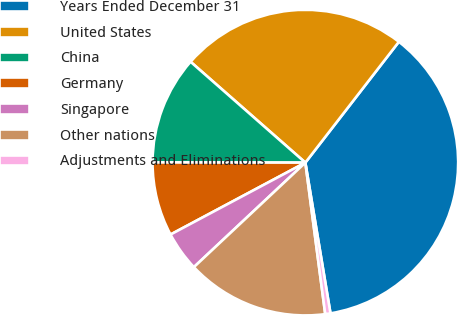<chart> <loc_0><loc_0><loc_500><loc_500><pie_chart><fcel>Years Ended December 31<fcel>United States<fcel>China<fcel>Germany<fcel>Singapore<fcel>Other nations<fcel>Adjustments and Eliminations<nl><fcel>36.89%<fcel>24.01%<fcel>11.45%<fcel>7.82%<fcel>4.19%<fcel>15.09%<fcel>0.55%<nl></chart> 